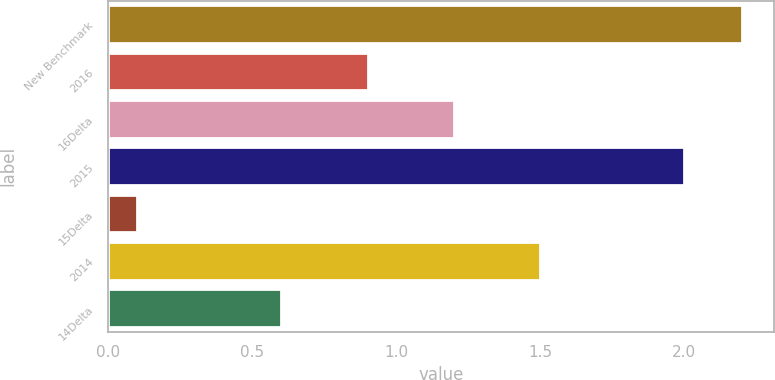Convert chart to OTSL. <chart><loc_0><loc_0><loc_500><loc_500><bar_chart><fcel>New Benchmark<fcel>2016<fcel>16Delta<fcel>2015<fcel>15Delta<fcel>2014<fcel>14Delta<nl><fcel>2.2<fcel>0.9<fcel>1.2<fcel>2<fcel>0.1<fcel>1.5<fcel>0.6<nl></chart> 